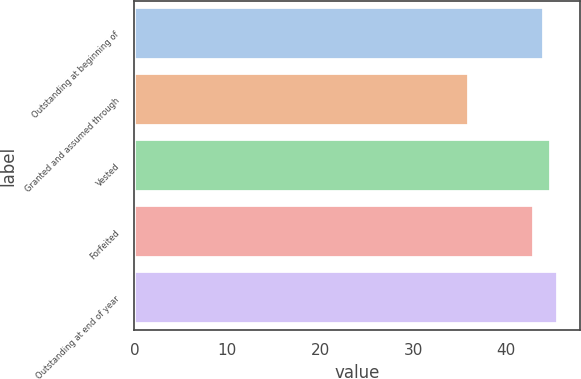Convert chart. <chart><loc_0><loc_0><loc_500><loc_500><bar_chart><fcel>Outstanding at beginning of<fcel>Granted and assumed through<fcel>Vested<fcel>Forfeited<fcel>Outstanding at end of year<nl><fcel>44<fcel>36<fcel>44.8<fcel>43<fcel>45.6<nl></chart> 